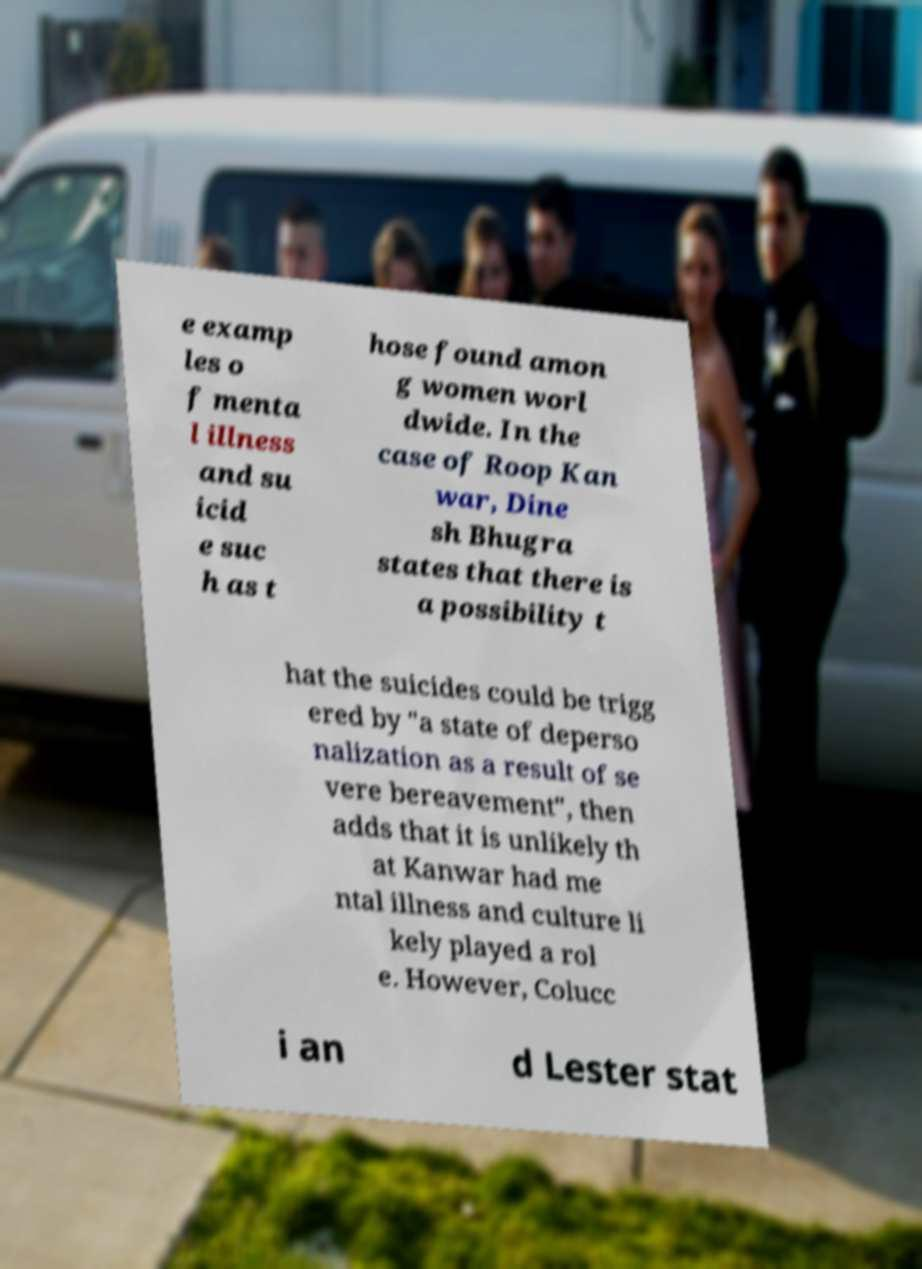Could you extract and type out the text from this image? e examp les o f menta l illness and su icid e suc h as t hose found amon g women worl dwide. In the case of Roop Kan war, Dine sh Bhugra states that there is a possibility t hat the suicides could be trigg ered by "a state of deperso nalization as a result of se vere bereavement", then adds that it is unlikely th at Kanwar had me ntal illness and culture li kely played a rol e. However, Colucc i an d Lester stat 